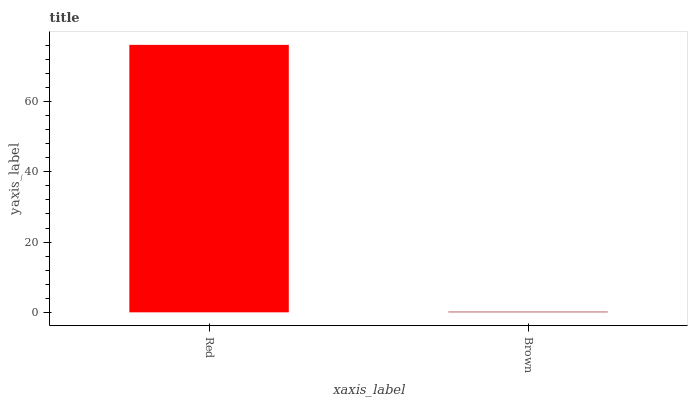Is Brown the maximum?
Answer yes or no. No. Is Red greater than Brown?
Answer yes or no. Yes. Is Brown less than Red?
Answer yes or no. Yes. Is Brown greater than Red?
Answer yes or no. No. Is Red less than Brown?
Answer yes or no. No. Is Red the high median?
Answer yes or no. Yes. Is Brown the low median?
Answer yes or no. Yes. Is Brown the high median?
Answer yes or no. No. Is Red the low median?
Answer yes or no. No. 